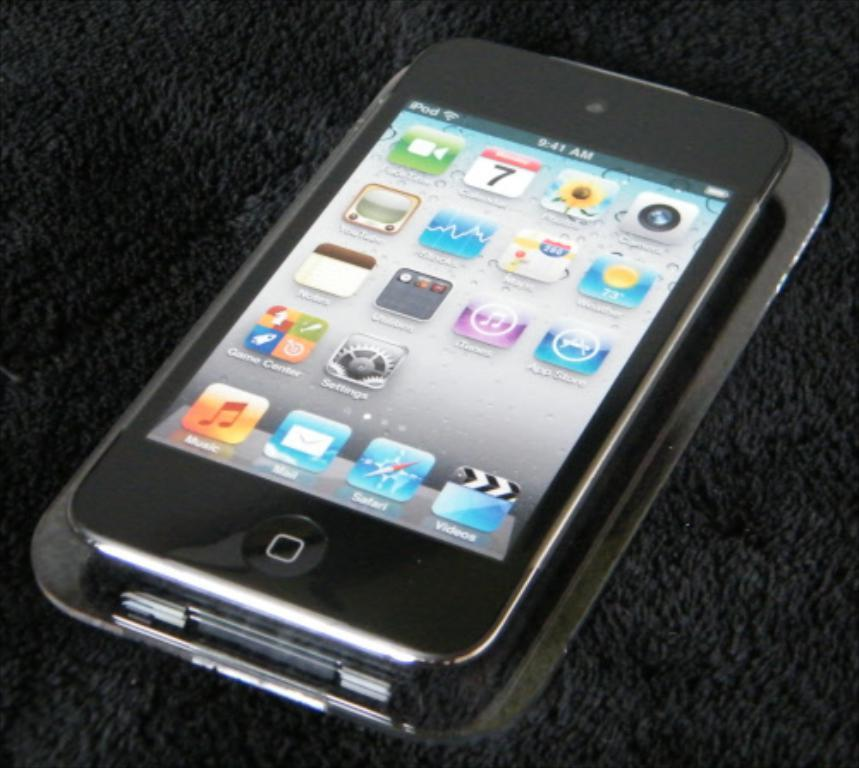<image>
Write a terse but informative summary of the picture. a cell phone with the time 9:41 AM shown on the display 